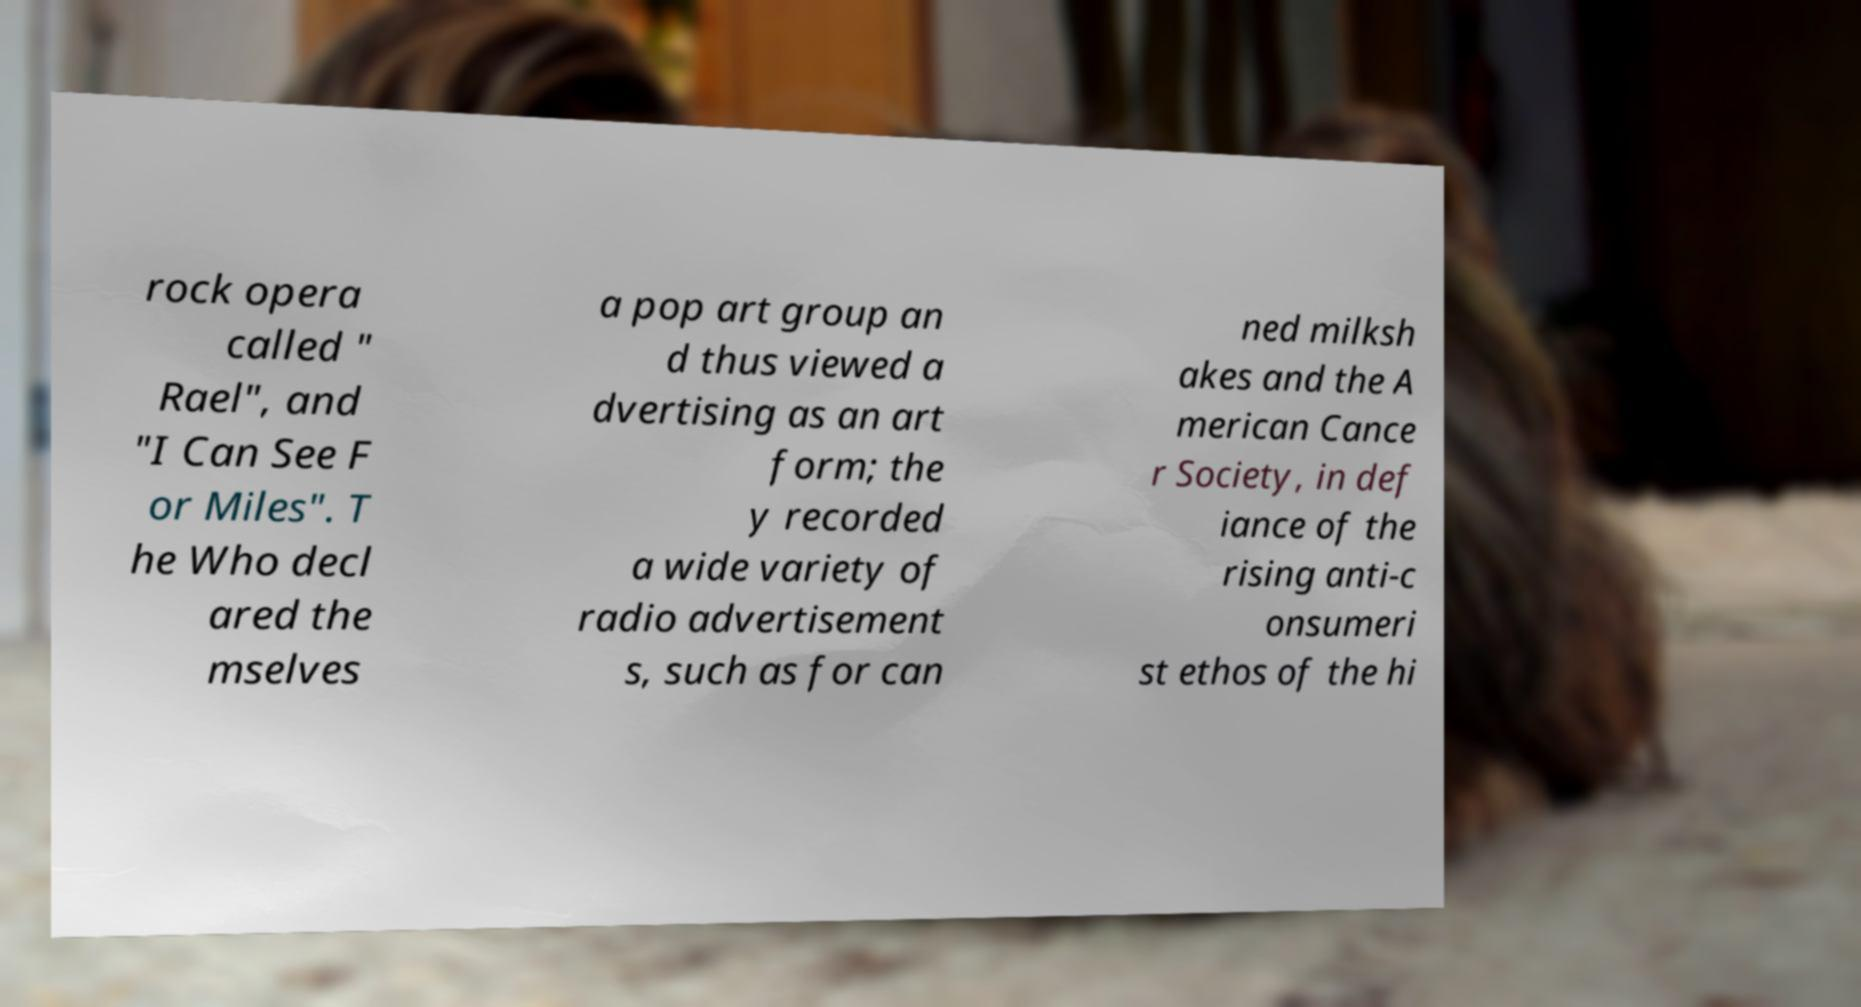What messages or text are displayed in this image? I need them in a readable, typed format. rock opera called " Rael", and "I Can See F or Miles". T he Who decl ared the mselves a pop art group an d thus viewed a dvertising as an art form; the y recorded a wide variety of radio advertisement s, such as for can ned milksh akes and the A merican Cance r Society, in def iance of the rising anti-c onsumeri st ethos of the hi 